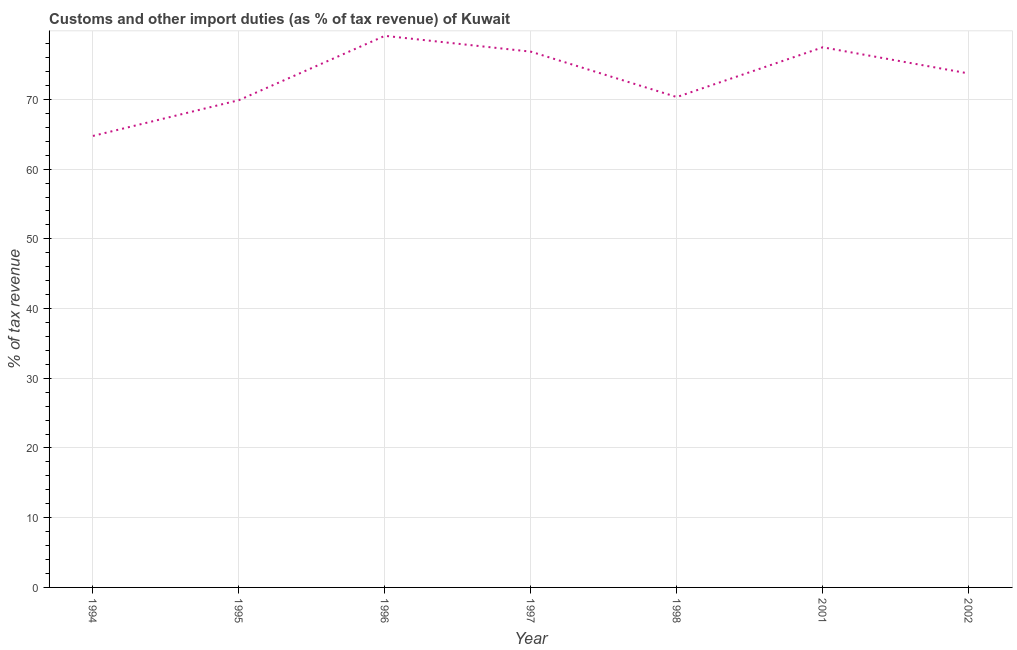What is the customs and other import duties in 1995?
Offer a terse response. 69.89. Across all years, what is the maximum customs and other import duties?
Give a very brief answer. 79.12. Across all years, what is the minimum customs and other import duties?
Offer a very short reply. 64.76. In which year was the customs and other import duties maximum?
Provide a short and direct response. 1996. What is the sum of the customs and other import duties?
Offer a very short reply. 512.17. What is the difference between the customs and other import duties in 1996 and 1997?
Give a very brief answer. 2.27. What is the average customs and other import duties per year?
Ensure brevity in your answer.  73.17. What is the median customs and other import duties?
Ensure brevity in your answer.  73.72. Do a majority of the years between 1994 and 2002 (inclusive) have customs and other import duties greater than 68 %?
Your answer should be compact. Yes. What is the ratio of the customs and other import duties in 1995 to that in 1997?
Make the answer very short. 0.91. Is the difference between the customs and other import duties in 1997 and 2002 greater than the difference between any two years?
Your answer should be very brief. No. What is the difference between the highest and the second highest customs and other import duties?
Offer a terse response. 1.64. What is the difference between the highest and the lowest customs and other import duties?
Ensure brevity in your answer.  14.36. In how many years, is the customs and other import duties greater than the average customs and other import duties taken over all years?
Offer a terse response. 4. Does the customs and other import duties monotonically increase over the years?
Offer a very short reply. No. How many years are there in the graph?
Provide a short and direct response. 7. What is the difference between two consecutive major ticks on the Y-axis?
Keep it short and to the point. 10. What is the title of the graph?
Provide a succinct answer. Customs and other import duties (as % of tax revenue) of Kuwait. What is the label or title of the X-axis?
Provide a short and direct response. Year. What is the label or title of the Y-axis?
Give a very brief answer. % of tax revenue. What is the % of tax revenue of 1994?
Your response must be concise. 64.76. What is the % of tax revenue in 1995?
Your response must be concise. 69.89. What is the % of tax revenue of 1996?
Make the answer very short. 79.12. What is the % of tax revenue in 1997?
Provide a short and direct response. 76.85. What is the % of tax revenue in 1998?
Provide a short and direct response. 70.34. What is the % of tax revenue in 2001?
Give a very brief answer. 77.48. What is the % of tax revenue of 2002?
Provide a short and direct response. 73.72. What is the difference between the % of tax revenue in 1994 and 1995?
Provide a succinct answer. -5.13. What is the difference between the % of tax revenue in 1994 and 1996?
Your answer should be compact. -14.36. What is the difference between the % of tax revenue in 1994 and 1997?
Provide a succinct answer. -12.09. What is the difference between the % of tax revenue in 1994 and 1998?
Offer a very short reply. -5.58. What is the difference between the % of tax revenue in 1994 and 2001?
Give a very brief answer. -12.72. What is the difference between the % of tax revenue in 1994 and 2002?
Make the answer very short. -8.96. What is the difference between the % of tax revenue in 1995 and 1996?
Your response must be concise. -9.23. What is the difference between the % of tax revenue in 1995 and 1997?
Ensure brevity in your answer.  -6.96. What is the difference between the % of tax revenue in 1995 and 1998?
Your response must be concise. -0.45. What is the difference between the % of tax revenue in 1995 and 2001?
Give a very brief answer. -7.58. What is the difference between the % of tax revenue in 1995 and 2002?
Your answer should be compact. -3.83. What is the difference between the % of tax revenue in 1996 and 1997?
Your answer should be compact. 2.27. What is the difference between the % of tax revenue in 1996 and 1998?
Your answer should be compact. 8.78. What is the difference between the % of tax revenue in 1996 and 2001?
Your answer should be very brief. 1.64. What is the difference between the % of tax revenue in 1996 and 2002?
Your response must be concise. 5.4. What is the difference between the % of tax revenue in 1997 and 1998?
Offer a very short reply. 6.51. What is the difference between the % of tax revenue in 1997 and 2001?
Provide a short and direct response. -0.63. What is the difference between the % of tax revenue in 1997 and 2002?
Keep it short and to the point. 3.13. What is the difference between the % of tax revenue in 1998 and 2001?
Offer a terse response. -7.14. What is the difference between the % of tax revenue in 1998 and 2002?
Make the answer very short. -3.38. What is the difference between the % of tax revenue in 2001 and 2002?
Make the answer very short. 3.75. What is the ratio of the % of tax revenue in 1994 to that in 1995?
Provide a succinct answer. 0.93. What is the ratio of the % of tax revenue in 1994 to that in 1996?
Make the answer very short. 0.82. What is the ratio of the % of tax revenue in 1994 to that in 1997?
Offer a very short reply. 0.84. What is the ratio of the % of tax revenue in 1994 to that in 1998?
Ensure brevity in your answer.  0.92. What is the ratio of the % of tax revenue in 1994 to that in 2001?
Ensure brevity in your answer.  0.84. What is the ratio of the % of tax revenue in 1994 to that in 2002?
Provide a succinct answer. 0.88. What is the ratio of the % of tax revenue in 1995 to that in 1996?
Keep it short and to the point. 0.88. What is the ratio of the % of tax revenue in 1995 to that in 1997?
Offer a very short reply. 0.91. What is the ratio of the % of tax revenue in 1995 to that in 1998?
Offer a very short reply. 0.99. What is the ratio of the % of tax revenue in 1995 to that in 2001?
Offer a terse response. 0.9. What is the ratio of the % of tax revenue in 1995 to that in 2002?
Provide a short and direct response. 0.95. What is the ratio of the % of tax revenue in 1996 to that in 1998?
Ensure brevity in your answer.  1.12. What is the ratio of the % of tax revenue in 1996 to that in 2002?
Offer a terse response. 1.07. What is the ratio of the % of tax revenue in 1997 to that in 1998?
Make the answer very short. 1.09. What is the ratio of the % of tax revenue in 1997 to that in 2001?
Your answer should be very brief. 0.99. What is the ratio of the % of tax revenue in 1997 to that in 2002?
Provide a short and direct response. 1.04. What is the ratio of the % of tax revenue in 1998 to that in 2001?
Provide a succinct answer. 0.91. What is the ratio of the % of tax revenue in 1998 to that in 2002?
Provide a succinct answer. 0.95. What is the ratio of the % of tax revenue in 2001 to that in 2002?
Keep it short and to the point. 1.05. 